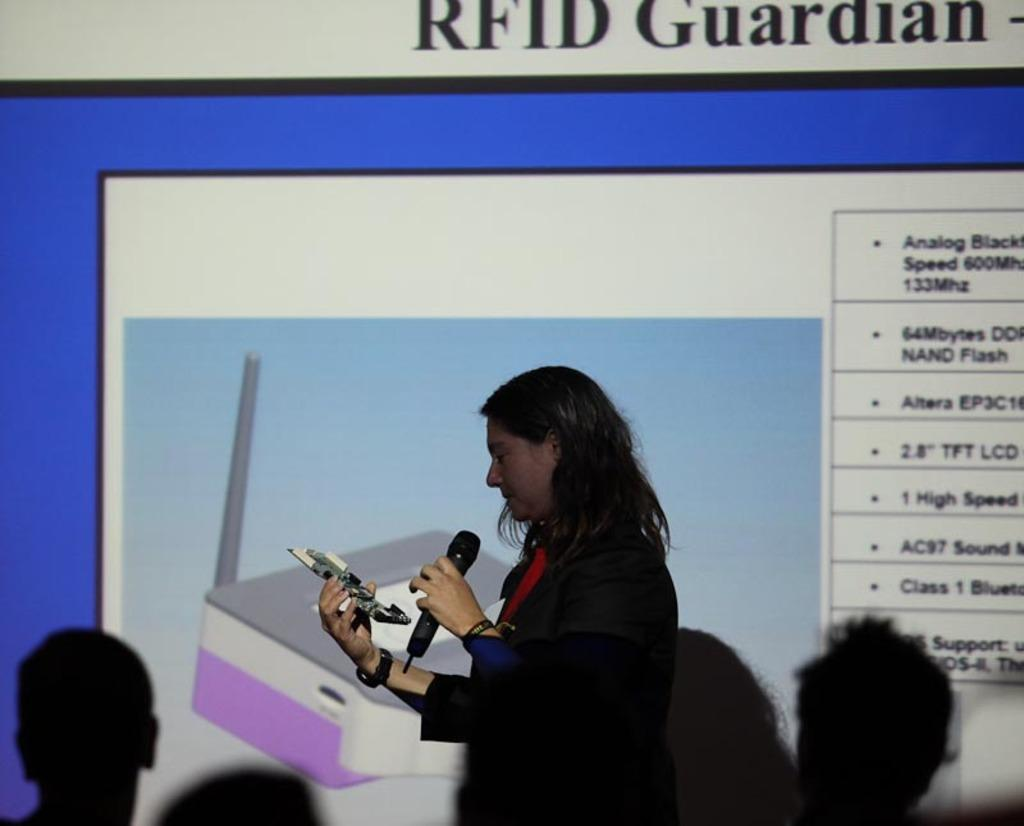What is the main subject of the image? The main subject of the image is a woman. What is the woman holding in the image? The woman is holding a microphone. Are there any other people in the image besides the woman? Yes, people are present in the image. What can be seen on the display in the image? There is a projector display in the image. What type of bird is flying over the woman's head in the image? There is no bird present in the image. What selection of items is the woman making in the image? The image does not show the woman making any selections; she is holding a microphone. 